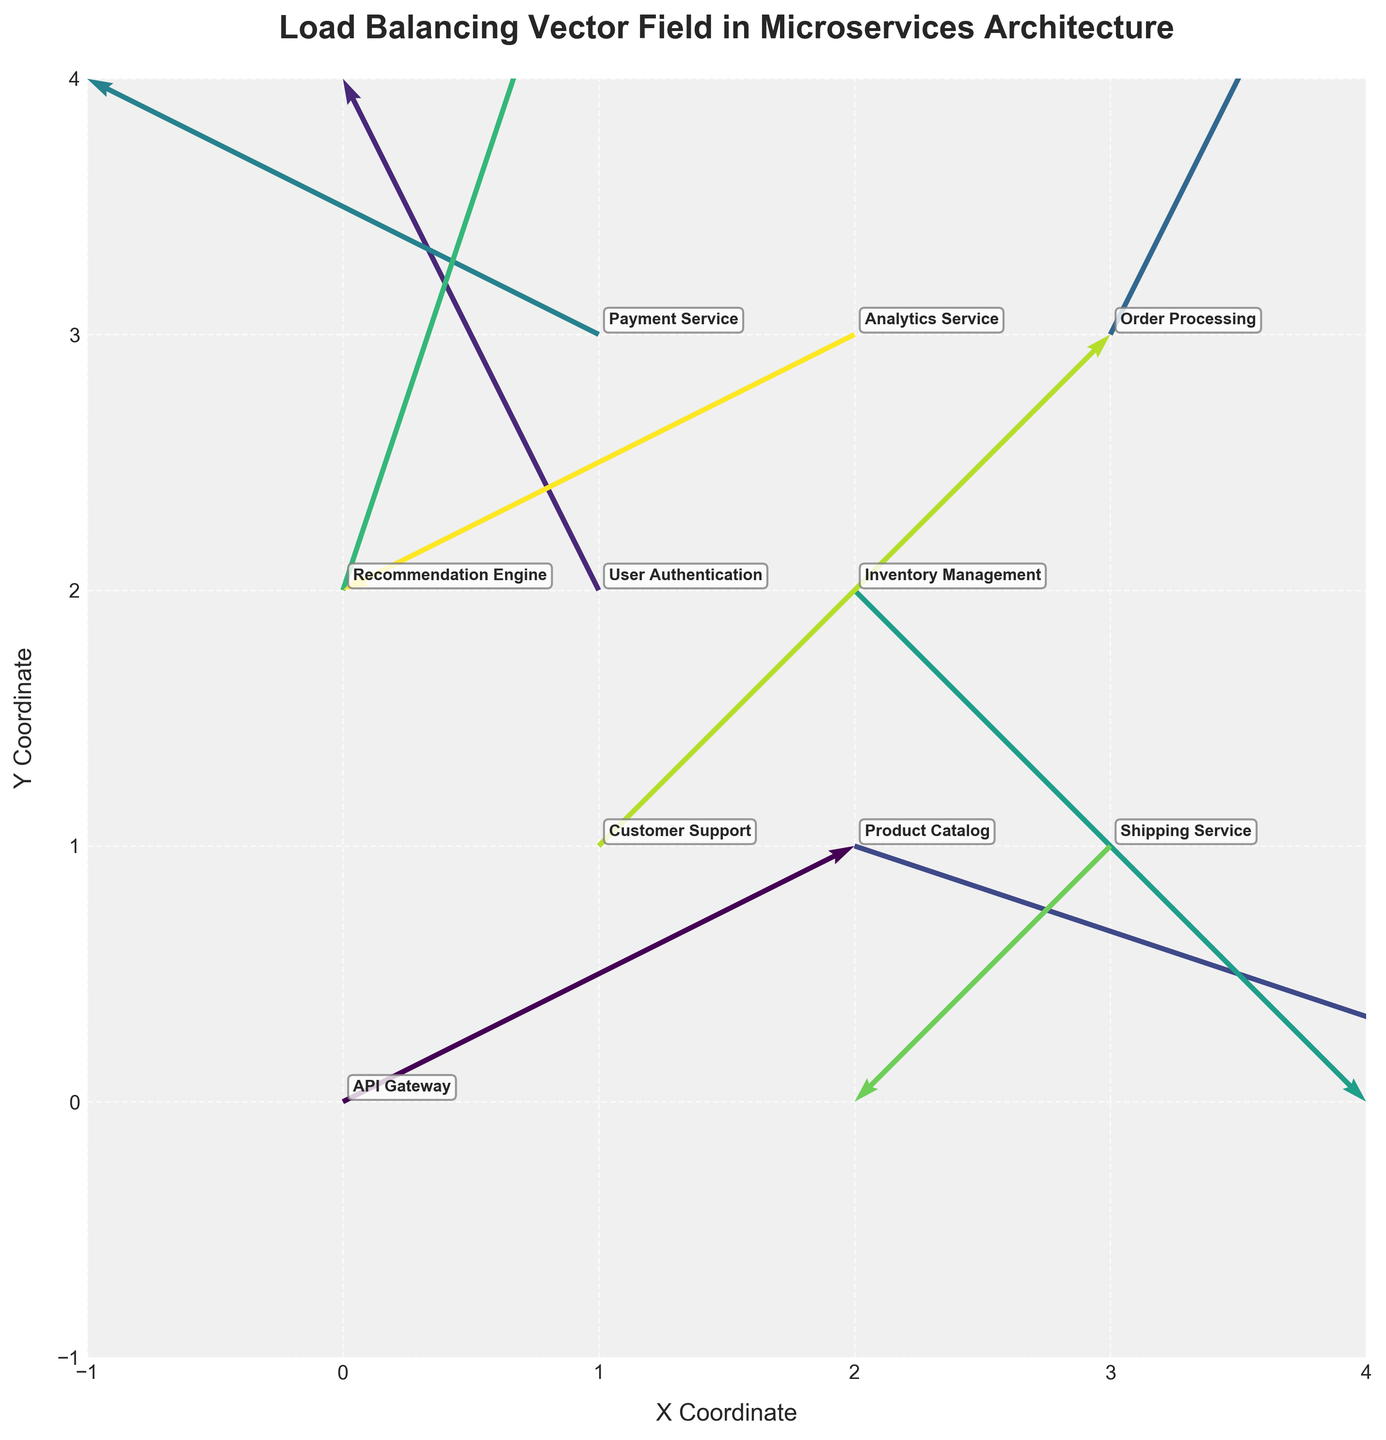what is the title of the plot? The plot's title is usually displayed prominently at the top of the figure.
Answer: Load Balancing Vector Field in Microservices Architecture How many services are shown in the plot? Each service is represented by a vector and is labeled. By counting the annotated service labels, we find the number of services.
Answer: 10 Which service has the vector with the highest magnitude? To find the service with the highest vector magnitude, calculate sqrt(u^2 + v^2) for each vector and compare. The highest magnitude vector belongs to the 'Product Catalog' with magnitude sqrt(3^2 + (-1)^2) = sqrt(10).
Answer: Product Catalog Where is the 'User Authentication' service located in the plot? Check the annotated label for 'User Authentication' and note its coordinates (x, y).
Answer: (1, 2) Which service vectors point towards the positive y direction? Look for vectors with positive v-components indicating an upward direction. These are 'API Gateway', 'User Authentication', 'Order Processing', 'Payment Service', 'Recommendation Engine', and 'Customer Support'.
Answer: API Gateway, User Authentication, Order Processing, Payment Service, Recommendation Engine, Customer Support Do any vectors point in the exact opposite direction? If so, which ones? To identify vectors pointing in opposite directions, compare their u and v components. The vectors for 'Product Catalog' (u=3,v=-1) and 'Analytics Service' (u=-2, v=-1) have opposite u-components, but not exactly opposite in all directions. Thus, no exact opposites exist.
Answer: None Which vectors have negative x-components? Vectors with negative u-components point leftward. Identify these services on the plot.
Answer: User Authentication, Payment Service, Shipping Service, Analytics Service Considering both directions and magnitudes, which service vector is closest in magnitude and direction to the 'Order Processing' service vector? To determine the vector closely matching 'Order Processing' (u=1, v=2), compare the magnitude sqrt(1^2 + 2^2) = sqrt(5) and vector direction with others. 'Customer Support' (u=2, v=2) has a similar direction but larger magnitude at sqrt(8).
Answer: Customer Support What is the average magnitude of the vectors in the plot? Compute the magnitude of each vector using sqrt(u^2 + v^2), sum them, and divide by the number of vectors (10). Magnitudes: 2.24, 2.24, 3.16, 2.24, 2.24, 2.83, 3.16, 1.41, 2.83, 2.24. Total = 24.59, average = 24.59/10.
Answer: 2.46 Which services have vectors located in the third quadrant of the plot? The third quadrant includes negative x and y coordinates. Check the x, y positions of each service and note those in this region. Since plot limits are -1 to 4, no service falls in the true third quadrant (lower-left) area.
Answer: None 